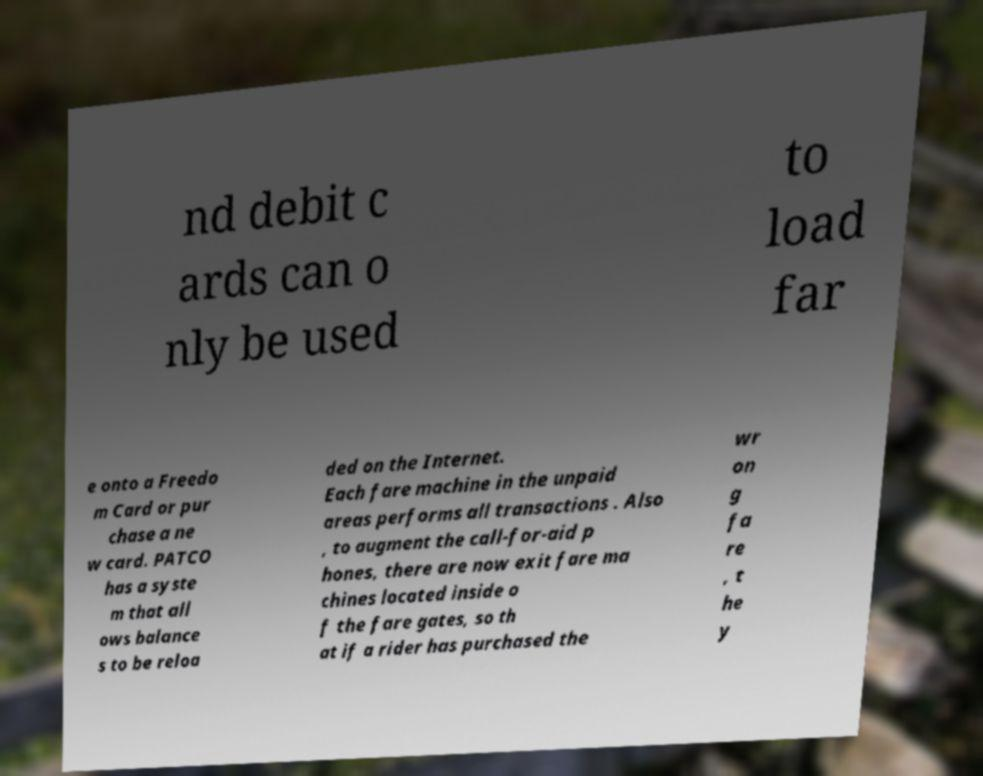Please identify and transcribe the text found in this image. nd debit c ards can o nly be used to load far e onto a Freedo m Card or pur chase a ne w card. PATCO has a syste m that all ows balance s to be reloa ded on the Internet. Each fare machine in the unpaid areas performs all transactions . Also , to augment the call-for-aid p hones, there are now exit fare ma chines located inside o f the fare gates, so th at if a rider has purchased the wr on g fa re , t he y 